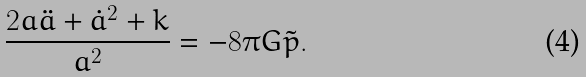Convert formula to latex. <formula><loc_0><loc_0><loc_500><loc_500>\frac { 2 a \ddot { a } + \dot { a } ^ { 2 } + k } { a ^ { 2 } } = - 8 \pi G \tilde { p } .</formula> 